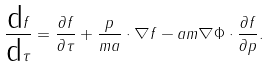Convert formula to latex. <formula><loc_0><loc_0><loc_500><loc_500>\frac { \text {d} f } { \text {d} \tau } & = \frac { \partial f } { \partial \tau } + \frac { p } { m a } \cdot \nabla f - a m \nabla \Phi \cdot \frac { \partial f } { \partial p } .</formula> 